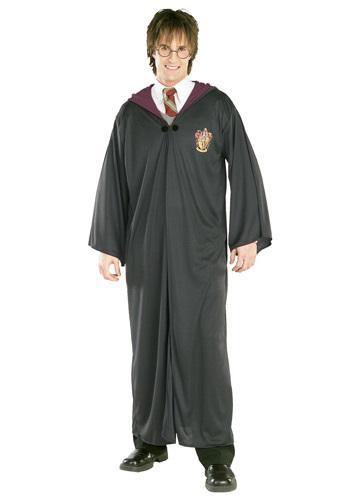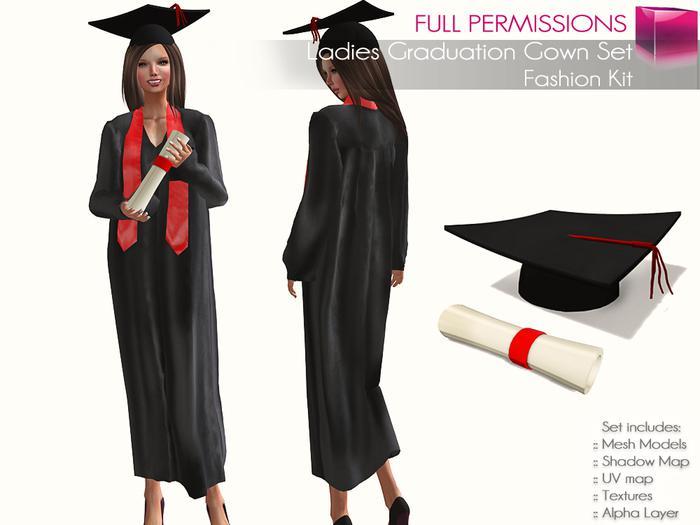The first image is the image on the left, the second image is the image on the right. Evaluate the accuracy of this statement regarding the images: "In one image, the gown is accessorized with a red scarf worn around the neck, hanging open at the waist.". Is it true? Answer yes or no. Yes. The first image is the image on the left, the second image is the image on the right. Examine the images to the left and right. Is the description "There is a women in one of the images." accurate? Answer yes or no. Yes. 